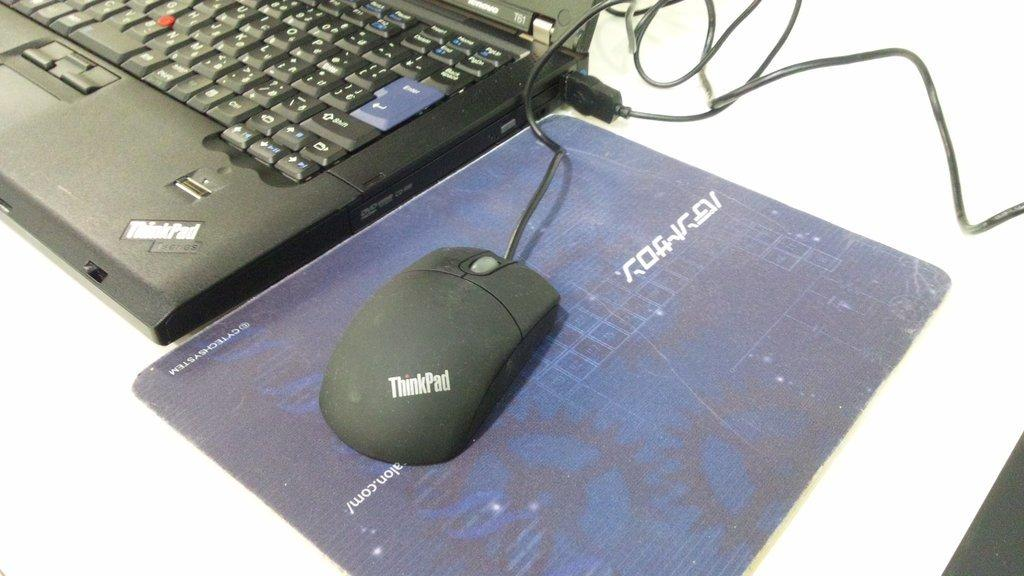What is on the mouse pad in the image? There is a mouse on the mouse pad. What electronic device is visible in the image? There is a laptop in the image. How is the laptop connected to a power source? The laptop is connected to a wire. On what surface is the laptop placed? The laptop is placed on a table. What type of record is being played on the laptop in the image? There is no record being played on the laptop in the image; it is a laptop connected to a wire and placed on a table. What thrill can be experienced by using the mouse on the mouse pad? The image does not convey any thrill associated with using the mouse on the mouse pad; it simply shows a mouse on a mouse pad. 